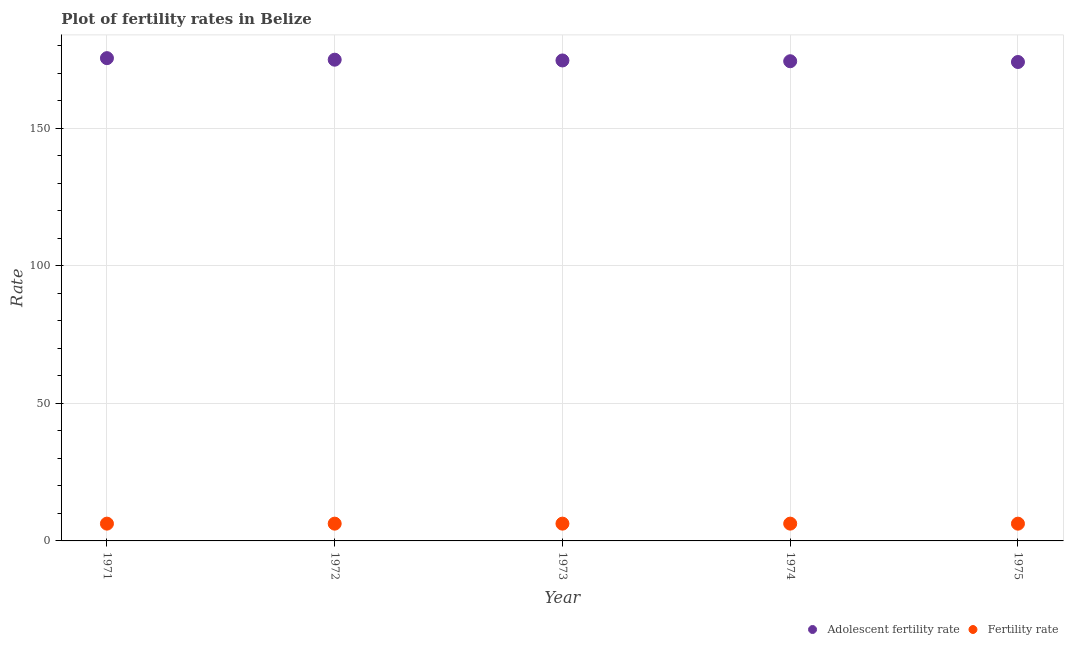Is the number of dotlines equal to the number of legend labels?
Give a very brief answer. Yes. What is the fertility rate in 1971?
Provide a short and direct response. 6.29. Across all years, what is the maximum fertility rate?
Keep it short and to the point. 6.29. Across all years, what is the minimum adolescent fertility rate?
Ensure brevity in your answer.  174.16. In which year was the fertility rate minimum?
Your answer should be compact. 1975. What is the total fertility rate in the graph?
Offer a terse response. 31.42. What is the difference between the fertility rate in 1974 and that in 1975?
Provide a succinct answer. 0.01. What is the difference between the adolescent fertility rate in 1975 and the fertility rate in 1973?
Your answer should be compact. 167.88. What is the average adolescent fertility rate per year?
Your answer should be very brief. 174.78. In the year 1972, what is the difference between the fertility rate and adolescent fertility rate?
Ensure brevity in your answer.  -168.72. What is the ratio of the adolescent fertility rate in 1973 to that in 1975?
Give a very brief answer. 1. What is the difference between the highest and the second highest adolescent fertility rate?
Your response must be concise. 0.56. What is the difference between the highest and the lowest adolescent fertility rate?
Provide a succinct answer. 1.4. Does the adolescent fertility rate monotonically increase over the years?
Ensure brevity in your answer.  No. Is the adolescent fertility rate strictly greater than the fertility rate over the years?
Provide a short and direct response. Yes. Is the adolescent fertility rate strictly less than the fertility rate over the years?
Ensure brevity in your answer.  No. Are the values on the major ticks of Y-axis written in scientific E-notation?
Provide a succinct answer. No. Does the graph contain any zero values?
Ensure brevity in your answer.  No. How many legend labels are there?
Offer a terse response. 2. How are the legend labels stacked?
Your answer should be compact. Horizontal. What is the title of the graph?
Your answer should be very brief. Plot of fertility rates in Belize. Does "Investment in Transport" appear as one of the legend labels in the graph?
Make the answer very short. No. What is the label or title of the Y-axis?
Ensure brevity in your answer.  Rate. What is the Rate of Adolescent fertility rate in 1971?
Your response must be concise. 175.56. What is the Rate of Fertility rate in 1971?
Your answer should be very brief. 6.29. What is the Rate in Adolescent fertility rate in 1972?
Your answer should be very brief. 175. What is the Rate of Fertility rate in 1972?
Provide a short and direct response. 6.28. What is the Rate in Adolescent fertility rate in 1973?
Provide a short and direct response. 174.72. What is the Rate in Fertility rate in 1973?
Provide a short and direct response. 6.29. What is the Rate of Adolescent fertility rate in 1974?
Your answer should be very brief. 174.44. What is the Rate of Fertility rate in 1974?
Your response must be concise. 6.29. What is the Rate in Adolescent fertility rate in 1975?
Keep it short and to the point. 174.16. What is the Rate in Fertility rate in 1975?
Give a very brief answer. 6.28. Across all years, what is the maximum Rate of Adolescent fertility rate?
Make the answer very short. 175.56. Across all years, what is the maximum Rate in Fertility rate?
Offer a very short reply. 6.29. Across all years, what is the minimum Rate of Adolescent fertility rate?
Keep it short and to the point. 174.16. Across all years, what is the minimum Rate in Fertility rate?
Provide a short and direct response. 6.28. What is the total Rate in Adolescent fertility rate in the graph?
Your response must be concise. 873.88. What is the total Rate in Fertility rate in the graph?
Provide a succinct answer. 31.42. What is the difference between the Rate of Adolescent fertility rate in 1971 and that in 1972?
Provide a succinct answer. 0.56. What is the difference between the Rate of Fertility rate in 1971 and that in 1972?
Make the answer very short. 0. What is the difference between the Rate in Adolescent fertility rate in 1971 and that in 1973?
Offer a terse response. 0.84. What is the difference between the Rate in Fertility rate in 1971 and that in 1973?
Offer a terse response. 0. What is the difference between the Rate in Adolescent fertility rate in 1971 and that in 1974?
Ensure brevity in your answer.  1.12. What is the difference between the Rate of Fertility rate in 1971 and that in 1974?
Your response must be concise. 0. What is the difference between the Rate of Adolescent fertility rate in 1972 and that in 1973?
Ensure brevity in your answer.  0.28. What is the difference between the Rate of Fertility rate in 1972 and that in 1973?
Provide a short and direct response. -0. What is the difference between the Rate in Adolescent fertility rate in 1972 and that in 1974?
Offer a very short reply. 0.56. What is the difference between the Rate of Fertility rate in 1972 and that in 1974?
Make the answer very short. -0. What is the difference between the Rate of Adolescent fertility rate in 1972 and that in 1975?
Give a very brief answer. 0.84. What is the difference between the Rate in Fertility rate in 1972 and that in 1975?
Your response must be concise. 0.01. What is the difference between the Rate in Adolescent fertility rate in 1973 and that in 1974?
Your response must be concise. 0.28. What is the difference between the Rate in Fertility rate in 1973 and that in 1974?
Keep it short and to the point. -0. What is the difference between the Rate in Adolescent fertility rate in 1973 and that in 1975?
Make the answer very short. 0.56. What is the difference between the Rate of Fertility rate in 1973 and that in 1975?
Provide a short and direct response. 0.01. What is the difference between the Rate in Adolescent fertility rate in 1974 and that in 1975?
Give a very brief answer. 0.28. What is the difference between the Rate of Fertility rate in 1974 and that in 1975?
Keep it short and to the point. 0.01. What is the difference between the Rate of Adolescent fertility rate in 1971 and the Rate of Fertility rate in 1972?
Your answer should be very brief. 169.28. What is the difference between the Rate in Adolescent fertility rate in 1971 and the Rate in Fertility rate in 1973?
Provide a short and direct response. 169.28. What is the difference between the Rate in Adolescent fertility rate in 1971 and the Rate in Fertility rate in 1974?
Make the answer very short. 169.27. What is the difference between the Rate in Adolescent fertility rate in 1971 and the Rate in Fertility rate in 1975?
Offer a very short reply. 169.28. What is the difference between the Rate in Adolescent fertility rate in 1972 and the Rate in Fertility rate in 1973?
Offer a terse response. 168.72. What is the difference between the Rate of Adolescent fertility rate in 1972 and the Rate of Fertility rate in 1974?
Your response must be concise. 168.71. What is the difference between the Rate of Adolescent fertility rate in 1972 and the Rate of Fertility rate in 1975?
Offer a terse response. 168.72. What is the difference between the Rate in Adolescent fertility rate in 1973 and the Rate in Fertility rate in 1974?
Your answer should be very brief. 168.43. What is the difference between the Rate of Adolescent fertility rate in 1973 and the Rate of Fertility rate in 1975?
Your answer should be compact. 168.44. What is the difference between the Rate of Adolescent fertility rate in 1974 and the Rate of Fertility rate in 1975?
Give a very brief answer. 168.16. What is the average Rate in Adolescent fertility rate per year?
Offer a terse response. 174.78. What is the average Rate in Fertility rate per year?
Provide a short and direct response. 6.28. In the year 1971, what is the difference between the Rate of Adolescent fertility rate and Rate of Fertility rate?
Ensure brevity in your answer.  169.27. In the year 1972, what is the difference between the Rate in Adolescent fertility rate and Rate in Fertility rate?
Make the answer very short. 168.72. In the year 1973, what is the difference between the Rate in Adolescent fertility rate and Rate in Fertility rate?
Make the answer very short. 168.44. In the year 1974, what is the difference between the Rate in Adolescent fertility rate and Rate in Fertility rate?
Offer a very short reply. 168.15. In the year 1975, what is the difference between the Rate of Adolescent fertility rate and Rate of Fertility rate?
Ensure brevity in your answer.  167.88. What is the ratio of the Rate of Fertility rate in 1971 to that in 1972?
Provide a succinct answer. 1. What is the ratio of the Rate of Adolescent fertility rate in 1971 to that in 1973?
Keep it short and to the point. 1. What is the ratio of the Rate of Adolescent fertility rate in 1971 to that in 1974?
Your answer should be compact. 1.01. What is the ratio of the Rate in Fertility rate in 1971 to that in 1974?
Your answer should be compact. 1. What is the ratio of the Rate in Adolescent fertility rate in 1971 to that in 1975?
Your answer should be very brief. 1.01. What is the ratio of the Rate of Fertility rate in 1971 to that in 1975?
Offer a terse response. 1. What is the ratio of the Rate in Fertility rate in 1972 to that in 1973?
Your response must be concise. 1. What is the ratio of the Rate of Adolescent fertility rate in 1972 to that in 1974?
Your answer should be very brief. 1. What is the ratio of the Rate of Fertility rate in 1972 to that in 1974?
Make the answer very short. 1. What is the ratio of the Rate of Adolescent fertility rate in 1972 to that in 1975?
Offer a terse response. 1. What is the ratio of the Rate in Fertility rate in 1972 to that in 1975?
Your response must be concise. 1. What is the ratio of the Rate in Adolescent fertility rate in 1973 to that in 1974?
Ensure brevity in your answer.  1. What is the ratio of the Rate in Fertility rate in 1973 to that in 1974?
Provide a short and direct response. 1. What is the ratio of the Rate in Fertility rate in 1973 to that in 1975?
Offer a very short reply. 1. What is the ratio of the Rate in Adolescent fertility rate in 1974 to that in 1975?
Provide a succinct answer. 1. What is the ratio of the Rate in Fertility rate in 1974 to that in 1975?
Your answer should be very brief. 1. What is the difference between the highest and the second highest Rate of Adolescent fertility rate?
Make the answer very short. 0.56. What is the difference between the highest and the second highest Rate in Fertility rate?
Provide a short and direct response. 0. What is the difference between the highest and the lowest Rate in Adolescent fertility rate?
Ensure brevity in your answer.  1.4. What is the difference between the highest and the lowest Rate in Fertility rate?
Give a very brief answer. 0.01. 